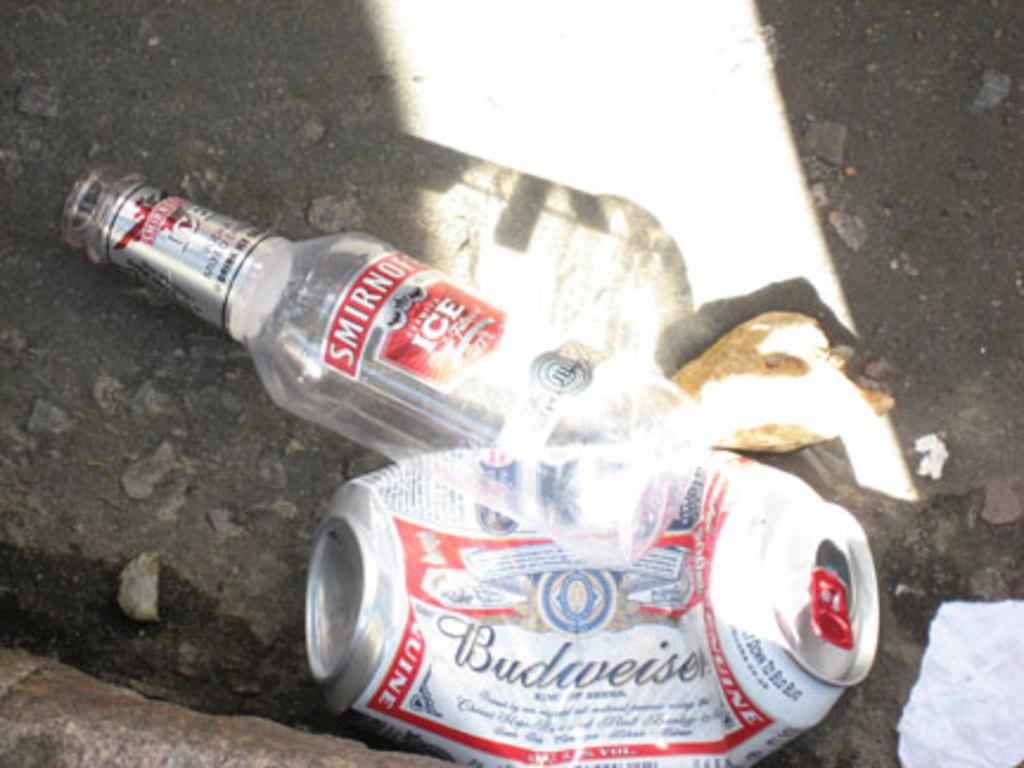What type of vodka is shown?
Give a very brief answer. Smirnoff. 